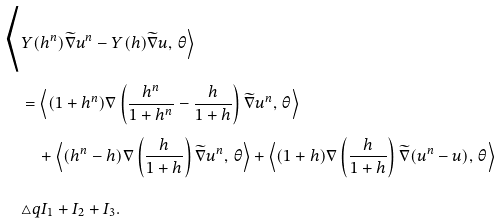<formula> <loc_0><loc_0><loc_500><loc_500>\Big < & Y ( h ^ { n } ) \widetilde { \nabla } u ^ { n } - Y ( h ) \widetilde { \nabla } u , \, \theta \Big > \\ & = \Big < ( 1 + h ^ { n } ) \nabla \left ( \frac { h ^ { n } } { 1 + h ^ { n } } - \frac { h } { 1 + h } \right ) \widetilde { \nabla } u ^ { n } , \, \theta \Big > \\ & \quad + \Big < ( h ^ { n } - h ) \nabla \left ( \frac { h } { 1 + h } \right ) \widetilde { \nabla } u ^ { n } , \, \theta \Big > + \Big < ( 1 + h ) \nabla \left ( \frac { h } { 1 + h } \right ) \widetilde { \nabla } ( u ^ { n } - u ) , \, \theta \Big > \\ & \triangle q { I } _ { 1 } + { I } _ { 2 } + { I } _ { 3 } .</formula> 